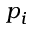Convert formula to latex. <formula><loc_0><loc_0><loc_500><loc_500>p _ { i }</formula> 